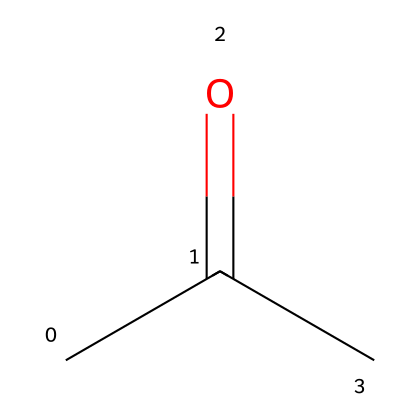How many carbon atoms are in this ketone? The SMILES representation CC(=O)C indicates that there are three carbon atoms present. The "CC" at the beginning signifies two carbon atoms, and the "C" after the carbonyl (C=O) indicates an additional carbon atom.
Answer: three What functional group is present in this chemical? The "C(=O)" portion of the SMILES indicates that there is a carbonyl group, which is characteristic of ketones. Ketones specifically have a carbonyl group located between carbon atoms.
Answer: carbonyl How many hydrogen atoms are in this ketone? The structure has three carbon atoms (C), and according to the valence rules, each carbon in a ketone can bond with enough hydrogens to have four total bonds. In this case, it will have six hydrogen atoms: two from one methyl (CH₃) and one from the other methyl (CH) adjacent to the carbonyl.
Answer: six What type of isomerism can occur with this ketone? Ketones can show structural isomerism, which occurs when compounds with the same molecular formula differ in the connectivity of their atoms. In this case, different arrangements of carbon chains can lead to distinct ketones.
Answer: structural isomerism What property of ketones affects their use in lubricants? Ketones generally have good solvency properties due to their polar nature, which allows them to dissolve and interact well with both organic and inorganic materials, making them suitable for lubrication applications.
Answer: solvency What is the general structure of ketones? The general structure of ketones consists of a carbonyl group (C=O) flanked by carbon atoms. In the displayed SMILES, the central carbonyl is surrounded by two carbon groups, confirming it as a ketone.
Answer: R-CO-R' 